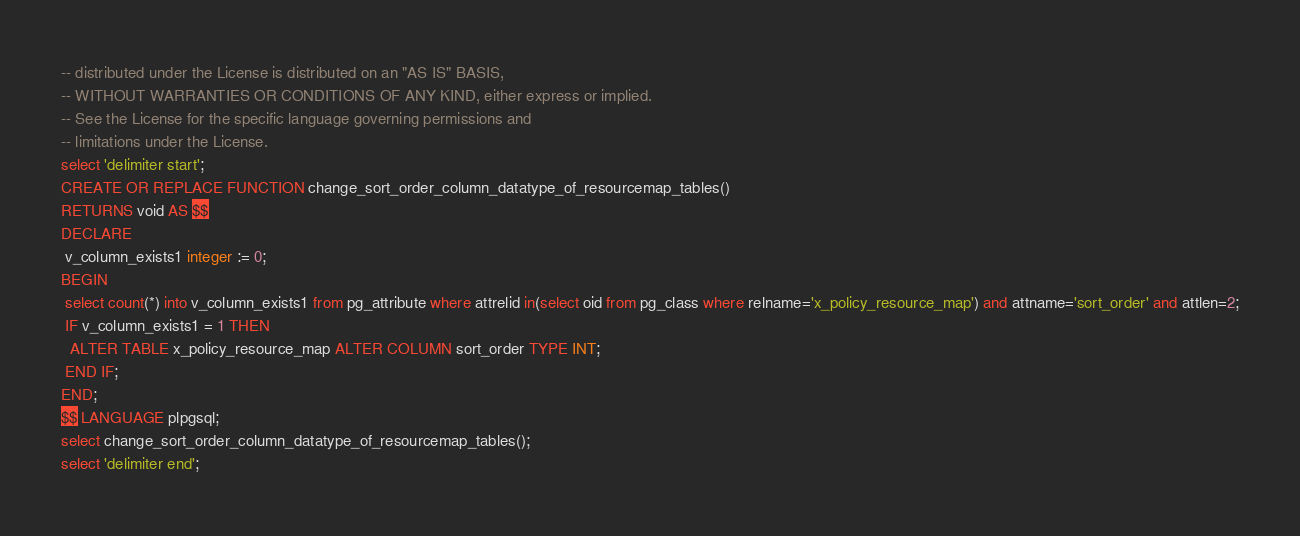Convert code to text. <code><loc_0><loc_0><loc_500><loc_500><_SQL_>-- distributed under the License is distributed on an "AS IS" BASIS,
-- WITHOUT WARRANTIES OR CONDITIONS OF ANY KIND, either express or implied.
-- See the License for the specific language governing permissions and
-- limitations under the License.
select 'delimiter start';
CREATE OR REPLACE FUNCTION change_sort_order_column_datatype_of_resourcemap_tables() 
RETURNS void AS $$
DECLARE
 v_column_exists1 integer := 0;
BEGIN
 select count(*) into v_column_exists1 from pg_attribute where attrelid in(select oid from pg_class where relname='x_policy_resource_map') and attname='sort_order' and attlen=2;
 IF v_column_exists1 = 1 THEN
  ALTER TABLE x_policy_resource_map ALTER COLUMN sort_order TYPE INT;
 END IF;
END;
$$ LANGUAGE plpgsql;
select change_sort_order_column_datatype_of_resourcemap_tables();
select 'delimiter end';</code> 